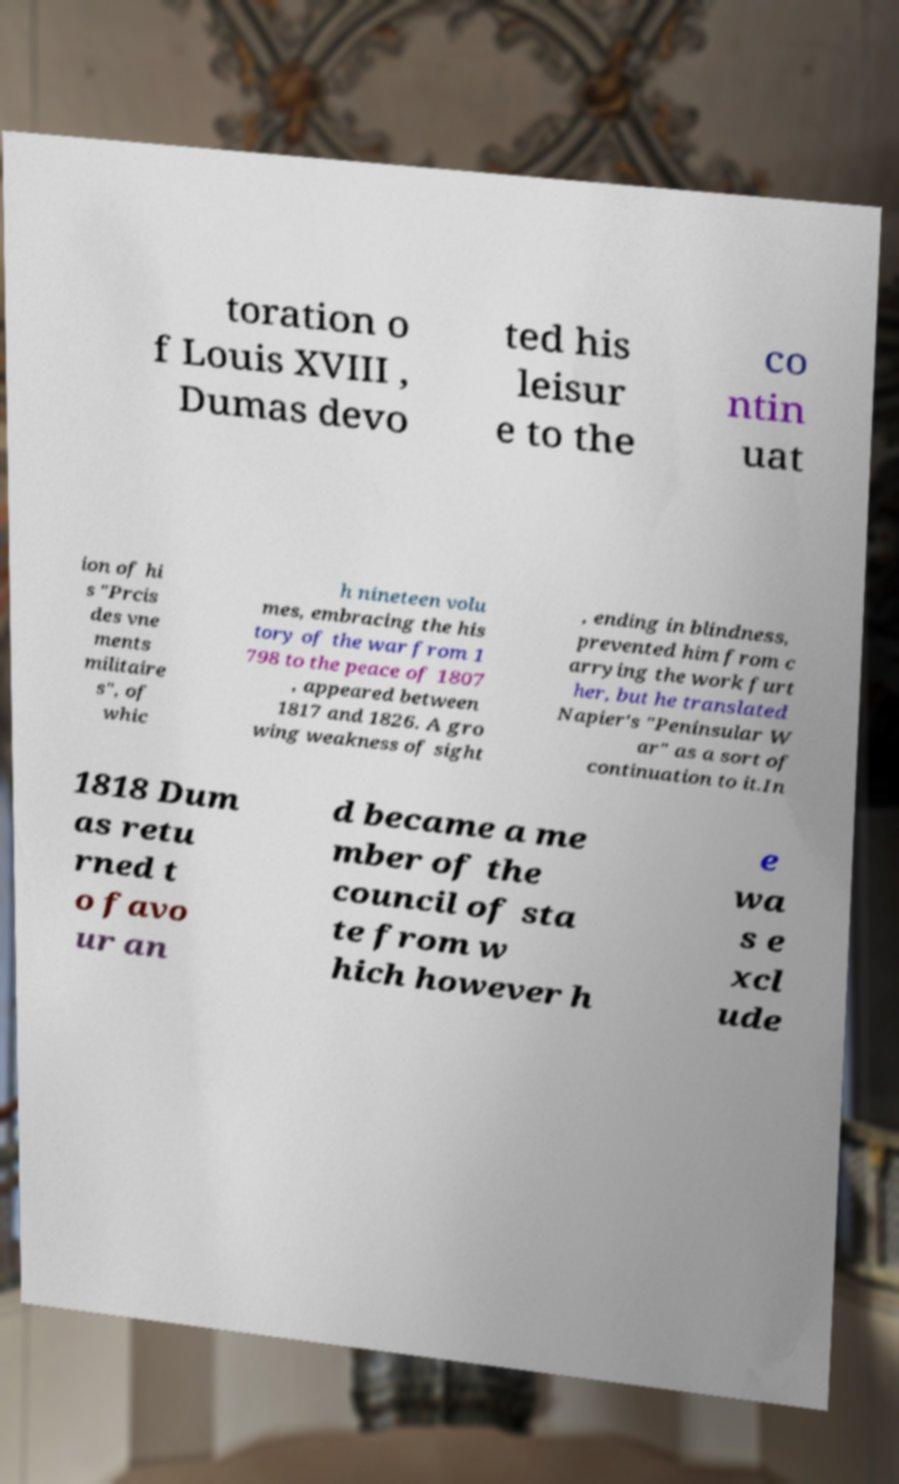I need the written content from this picture converted into text. Can you do that? toration o f Louis XVIII , Dumas devo ted his leisur e to the co ntin uat ion of hi s "Prcis des vne ments militaire s", of whic h nineteen volu mes, embracing the his tory of the war from 1 798 to the peace of 1807 , appeared between 1817 and 1826. A gro wing weakness of sight , ending in blindness, prevented him from c arrying the work furt her, but he translated Napier's "Peninsular W ar" as a sort of continuation to it.In 1818 Dum as retu rned t o favo ur an d became a me mber of the council of sta te from w hich however h e wa s e xcl ude 